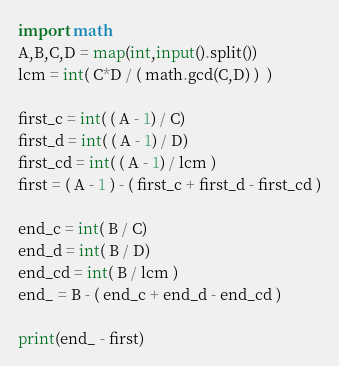Convert code to text. <code><loc_0><loc_0><loc_500><loc_500><_Python_>import math
A,B,C,D = map(int,input().split())
lcm = int( C*D / ( math.gcd(C,D) )  )

first_c = int( ( A - 1) / C)
first_d = int( ( A - 1) / D)
first_cd = int( ( A - 1) / lcm )
first = ( A - 1 ) - ( first_c + first_d - first_cd )

end_c = int( B / C)
end_d = int( B / D)
end_cd = int( B / lcm )
end_ = B - ( end_c + end_d - end_cd )

print(end_ - first)
</code> 